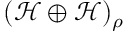Convert formula to latex. <formula><loc_0><loc_0><loc_500><loc_500>( \mathcal { H } \oplus \mathcal { H } ) _ { \rho }</formula> 